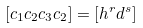Convert formula to latex. <formula><loc_0><loc_0><loc_500><loc_500>[ c _ { 1 } c _ { 2 } c _ { 3 } c _ { 2 } ] = [ h ^ { r } d ^ { s } ]</formula> 